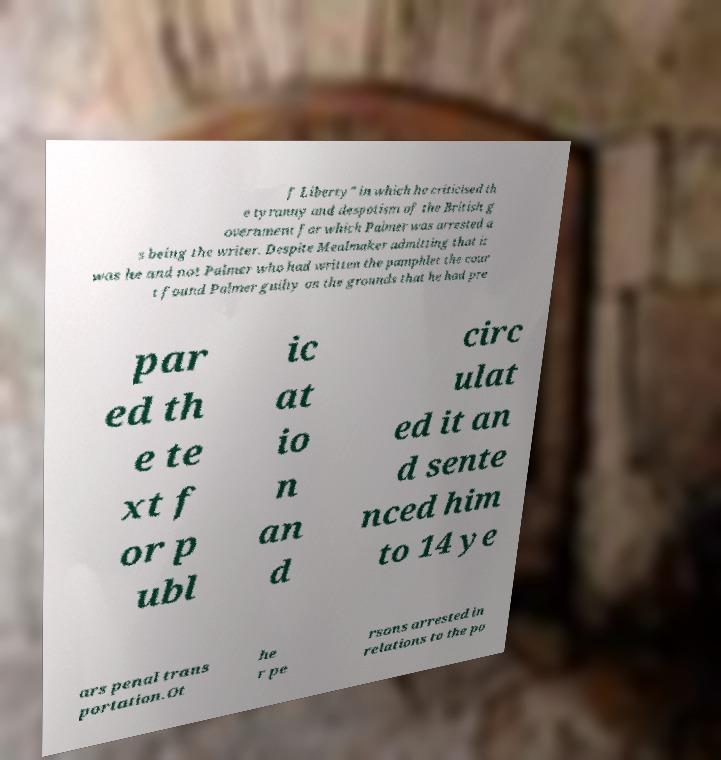Can you read and provide the text displayed in the image?This photo seems to have some interesting text. Can you extract and type it out for me? f Liberty" in which he criticised th e tyranny and despotism of the British g overnment for which Palmer was arrested a s being the writer. Despite Mealmaker admitting that it was he and not Palmer who had written the pamphlet the cour t found Palmer guilty on the grounds that he had pre par ed th e te xt f or p ubl ic at io n an d circ ulat ed it an d sente nced him to 14 ye ars penal trans portation.Ot he r pe rsons arrested in relations to the po 